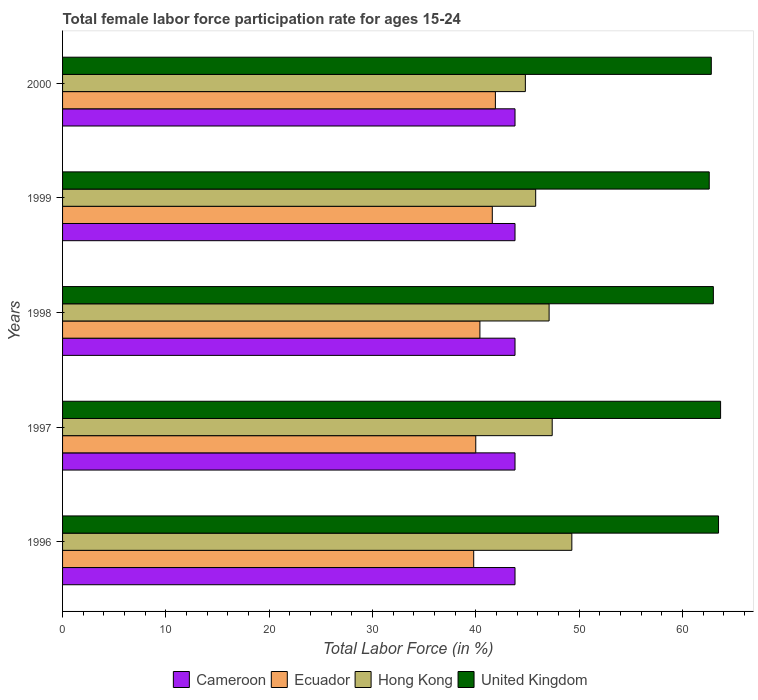How many different coloured bars are there?
Keep it short and to the point. 4. Are the number of bars per tick equal to the number of legend labels?
Your answer should be very brief. Yes. How many bars are there on the 1st tick from the bottom?
Your answer should be compact. 4. What is the label of the 5th group of bars from the top?
Provide a short and direct response. 1996. In how many cases, is the number of bars for a given year not equal to the number of legend labels?
Ensure brevity in your answer.  0. What is the female labor force participation rate in United Kingdom in 1999?
Give a very brief answer. 62.6. Across all years, what is the maximum female labor force participation rate in United Kingdom?
Keep it short and to the point. 63.7. Across all years, what is the minimum female labor force participation rate in United Kingdom?
Ensure brevity in your answer.  62.6. In which year was the female labor force participation rate in Ecuador maximum?
Give a very brief answer. 2000. In which year was the female labor force participation rate in Cameroon minimum?
Your answer should be compact. 1996. What is the total female labor force participation rate in Hong Kong in the graph?
Provide a succinct answer. 234.4. What is the difference between the female labor force participation rate in Cameroon in 1997 and that in 1999?
Your response must be concise. 0. What is the average female labor force participation rate in Cameroon per year?
Offer a terse response. 43.8. In the year 1997, what is the difference between the female labor force participation rate in Cameroon and female labor force participation rate in Ecuador?
Your response must be concise. 3.8. What is the ratio of the female labor force participation rate in Ecuador in 1996 to that in 1998?
Offer a very short reply. 0.99. Is the female labor force participation rate in Hong Kong in 1998 less than that in 1999?
Offer a terse response. No. What is the difference between the highest and the second highest female labor force participation rate in Ecuador?
Ensure brevity in your answer.  0.3. What is the difference between the highest and the lowest female labor force participation rate in United Kingdom?
Offer a terse response. 1.1. In how many years, is the female labor force participation rate in Hong Kong greater than the average female labor force participation rate in Hong Kong taken over all years?
Make the answer very short. 3. What does the 1st bar from the top in 1998 represents?
Ensure brevity in your answer.  United Kingdom. Are all the bars in the graph horizontal?
Offer a terse response. Yes. How many years are there in the graph?
Keep it short and to the point. 5. Does the graph contain grids?
Offer a terse response. No. What is the title of the graph?
Make the answer very short. Total female labor force participation rate for ages 15-24. Does "Mauritius" appear as one of the legend labels in the graph?
Your answer should be compact. No. What is the label or title of the X-axis?
Keep it short and to the point. Total Labor Force (in %). What is the label or title of the Y-axis?
Provide a short and direct response. Years. What is the Total Labor Force (in %) of Cameroon in 1996?
Your answer should be very brief. 43.8. What is the Total Labor Force (in %) in Ecuador in 1996?
Your answer should be very brief. 39.8. What is the Total Labor Force (in %) of Hong Kong in 1996?
Make the answer very short. 49.3. What is the Total Labor Force (in %) in United Kingdom in 1996?
Give a very brief answer. 63.5. What is the Total Labor Force (in %) in Cameroon in 1997?
Give a very brief answer. 43.8. What is the Total Labor Force (in %) in Ecuador in 1997?
Offer a very short reply. 40. What is the Total Labor Force (in %) of Hong Kong in 1997?
Offer a terse response. 47.4. What is the Total Labor Force (in %) in United Kingdom in 1997?
Give a very brief answer. 63.7. What is the Total Labor Force (in %) in Cameroon in 1998?
Offer a very short reply. 43.8. What is the Total Labor Force (in %) in Ecuador in 1998?
Make the answer very short. 40.4. What is the Total Labor Force (in %) in Hong Kong in 1998?
Your answer should be compact. 47.1. What is the Total Labor Force (in %) of United Kingdom in 1998?
Your answer should be compact. 63. What is the Total Labor Force (in %) in Cameroon in 1999?
Provide a short and direct response. 43.8. What is the Total Labor Force (in %) in Ecuador in 1999?
Your answer should be very brief. 41.6. What is the Total Labor Force (in %) of Hong Kong in 1999?
Your answer should be very brief. 45.8. What is the Total Labor Force (in %) in United Kingdom in 1999?
Make the answer very short. 62.6. What is the Total Labor Force (in %) of Cameroon in 2000?
Offer a very short reply. 43.8. What is the Total Labor Force (in %) in Ecuador in 2000?
Offer a very short reply. 41.9. What is the Total Labor Force (in %) of Hong Kong in 2000?
Your answer should be compact. 44.8. What is the Total Labor Force (in %) in United Kingdom in 2000?
Keep it short and to the point. 62.8. Across all years, what is the maximum Total Labor Force (in %) of Cameroon?
Make the answer very short. 43.8. Across all years, what is the maximum Total Labor Force (in %) of Ecuador?
Keep it short and to the point. 41.9. Across all years, what is the maximum Total Labor Force (in %) of Hong Kong?
Your response must be concise. 49.3. Across all years, what is the maximum Total Labor Force (in %) of United Kingdom?
Offer a very short reply. 63.7. Across all years, what is the minimum Total Labor Force (in %) in Cameroon?
Offer a terse response. 43.8. Across all years, what is the minimum Total Labor Force (in %) in Ecuador?
Give a very brief answer. 39.8. Across all years, what is the minimum Total Labor Force (in %) of Hong Kong?
Offer a very short reply. 44.8. Across all years, what is the minimum Total Labor Force (in %) in United Kingdom?
Give a very brief answer. 62.6. What is the total Total Labor Force (in %) in Cameroon in the graph?
Make the answer very short. 219. What is the total Total Labor Force (in %) in Ecuador in the graph?
Give a very brief answer. 203.7. What is the total Total Labor Force (in %) in Hong Kong in the graph?
Keep it short and to the point. 234.4. What is the total Total Labor Force (in %) in United Kingdom in the graph?
Provide a short and direct response. 315.6. What is the difference between the Total Labor Force (in %) of Cameroon in 1996 and that in 1997?
Your response must be concise. 0. What is the difference between the Total Labor Force (in %) in Ecuador in 1996 and that in 1997?
Ensure brevity in your answer.  -0.2. What is the difference between the Total Labor Force (in %) in United Kingdom in 1996 and that in 1997?
Offer a terse response. -0.2. What is the difference between the Total Labor Force (in %) in Cameroon in 1996 and that in 1998?
Offer a terse response. 0. What is the difference between the Total Labor Force (in %) of Ecuador in 1996 and that in 1998?
Provide a succinct answer. -0.6. What is the difference between the Total Labor Force (in %) in Hong Kong in 1996 and that in 1998?
Provide a succinct answer. 2.2. What is the difference between the Total Labor Force (in %) of Ecuador in 1996 and that in 1999?
Your answer should be very brief. -1.8. What is the difference between the Total Labor Force (in %) in Hong Kong in 1996 and that in 1999?
Provide a short and direct response. 3.5. What is the difference between the Total Labor Force (in %) in Ecuador in 1996 and that in 2000?
Keep it short and to the point. -2.1. What is the difference between the Total Labor Force (in %) in Hong Kong in 1996 and that in 2000?
Provide a succinct answer. 4.5. What is the difference between the Total Labor Force (in %) of United Kingdom in 1996 and that in 2000?
Offer a very short reply. 0.7. What is the difference between the Total Labor Force (in %) of United Kingdom in 1997 and that in 1998?
Offer a very short reply. 0.7. What is the difference between the Total Labor Force (in %) in Cameroon in 1997 and that in 1999?
Make the answer very short. 0. What is the difference between the Total Labor Force (in %) of United Kingdom in 1997 and that in 1999?
Make the answer very short. 1.1. What is the difference between the Total Labor Force (in %) in Ecuador in 1997 and that in 2000?
Provide a succinct answer. -1.9. What is the difference between the Total Labor Force (in %) of Hong Kong in 1997 and that in 2000?
Your response must be concise. 2.6. What is the difference between the Total Labor Force (in %) in Ecuador in 1998 and that in 2000?
Keep it short and to the point. -1.5. What is the difference between the Total Labor Force (in %) in Hong Kong in 1998 and that in 2000?
Offer a terse response. 2.3. What is the difference between the Total Labor Force (in %) in United Kingdom in 1998 and that in 2000?
Make the answer very short. 0.2. What is the difference between the Total Labor Force (in %) of Ecuador in 1999 and that in 2000?
Your answer should be very brief. -0.3. What is the difference between the Total Labor Force (in %) of United Kingdom in 1999 and that in 2000?
Offer a very short reply. -0.2. What is the difference between the Total Labor Force (in %) in Cameroon in 1996 and the Total Labor Force (in %) in Ecuador in 1997?
Keep it short and to the point. 3.8. What is the difference between the Total Labor Force (in %) in Cameroon in 1996 and the Total Labor Force (in %) in United Kingdom in 1997?
Offer a terse response. -19.9. What is the difference between the Total Labor Force (in %) in Ecuador in 1996 and the Total Labor Force (in %) in United Kingdom in 1997?
Your response must be concise. -23.9. What is the difference between the Total Labor Force (in %) in Hong Kong in 1996 and the Total Labor Force (in %) in United Kingdom in 1997?
Give a very brief answer. -14.4. What is the difference between the Total Labor Force (in %) of Cameroon in 1996 and the Total Labor Force (in %) of United Kingdom in 1998?
Make the answer very short. -19.2. What is the difference between the Total Labor Force (in %) of Ecuador in 1996 and the Total Labor Force (in %) of United Kingdom in 1998?
Your answer should be very brief. -23.2. What is the difference between the Total Labor Force (in %) in Hong Kong in 1996 and the Total Labor Force (in %) in United Kingdom in 1998?
Keep it short and to the point. -13.7. What is the difference between the Total Labor Force (in %) in Cameroon in 1996 and the Total Labor Force (in %) in Ecuador in 1999?
Offer a terse response. 2.2. What is the difference between the Total Labor Force (in %) in Cameroon in 1996 and the Total Labor Force (in %) in Hong Kong in 1999?
Your response must be concise. -2. What is the difference between the Total Labor Force (in %) of Cameroon in 1996 and the Total Labor Force (in %) of United Kingdom in 1999?
Ensure brevity in your answer.  -18.8. What is the difference between the Total Labor Force (in %) of Ecuador in 1996 and the Total Labor Force (in %) of Hong Kong in 1999?
Your answer should be compact. -6. What is the difference between the Total Labor Force (in %) of Ecuador in 1996 and the Total Labor Force (in %) of United Kingdom in 1999?
Keep it short and to the point. -22.8. What is the difference between the Total Labor Force (in %) of Cameroon in 1996 and the Total Labor Force (in %) of Hong Kong in 2000?
Your answer should be very brief. -1. What is the difference between the Total Labor Force (in %) of Ecuador in 1996 and the Total Labor Force (in %) of Hong Kong in 2000?
Provide a short and direct response. -5. What is the difference between the Total Labor Force (in %) in Cameroon in 1997 and the Total Labor Force (in %) in Ecuador in 1998?
Your response must be concise. 3.4. What is the difference between the Total Labor Force (in %) of Cameroon in 1997 and the Total Labor Force (in %) of United Kingdom in 1998?
Your answer should be very brief. -19.2. What is the difference between the Total Labor Force (in %) of Ecuador in 1997 and the Total Labor Force (in %) of Hong Kong in 1998?
Provide a succinct answer. -7.1. What is the difference between the Total Labor Force (in %) in Ecuador in 1997 and the Total Labor Force (in %) in United Kingdom in 1998?
Ensure brevity in your answer.  -23. What is the difference between the Total Labor Force (in %) of Hong Kong in 1997 and the Total Labor Force (in %) of United Kingdom in 1998?
Your answer should be compact. -15.6. What is the difference between the Total Labor Force (in %) in Cameroon in 1997 and the Total Labor Force (in %) in Hong Kong in 1999?
Your response must be concise. -2. What is the difference between the Total Labor Force (in %) of Cameroon in 1997 and the Total Labor Force (in %) of United Kingdom in 1999?
Your answer should be compact. -18.8. What is the difference between the Total Labor Force (in %) in Ecuador in 1997 and the Total Labor Force (in %) in Hong Kong in 1999?
Ensure brevity in your answer.  -5.8. What is the difference between the Total Labor Force (in %) in Ecuador in 1997 and the Total Labor Force (in %) in United Kingdom in 1999?
Offer a terse response. -22.6. What is the difference between the Total Labor Force (in %) in Hong Kong in 1997 and the Total Labor Force (in %) in United Kingdom in 1999?
Give a very brief answer. -15.2. What is the difference between the Total Labor Force (in %) of Cameroon in 1997 and the Total Labor Force (in %) of Ecuador in 2000?
Provide a succinct answer. 1.9. What is the difference between the Total Labor Force (in %) of Cameroon in 1997 and the Total Labor Force (in %) of United Kingdom in 2000?
Offer a very short reply. -19. What is the difference between the Total Labor Force (in %) in Ecuador in 1997 and the Total Labor Force (in %) in United Kingdom in 2000?
Your answer should be compact. -22.8. What is the difference between the Total Labor Force (in %) in Hong Kong in 1997 and the Total Labor Force (in %) in United Kingdom in 2000?
Ensure brevity in your answer.  -15.4. What is the difference between the Total Labor Force (in %) of Cameroon in 1998 and the Total Labor Force (in %) of Ecuador in 1999?
Ensure brevity in your answer.  2.2. What is the difference between the Total Labor Force (in %) in Cameroon in 1998 and the Total Labor Force (in %) in Hong Kong in 1999?
Ensure brevity in your answer.  -2. What is the difference between the Total Labor Force (in %) of Cameroon in 1998 and the Total Labor Force (in %) of United Kingdom in 1999?
Keep it short and to the point. -18.8. What is the difference between the Total Labor Force (in %) in Ecuador in 1998 and the Total Labor Force (in %) in United Kingdom in 1999?
Make the answer very short. -22.2. What is the difference between the Total Labor Force (in %) in Hong Kong in 1998 and the Total Labor Force (in %) in United Kingdom in 1999?
Keep it short and to the point. -15.5. What is the difference between the Total Labor Force (in %) in Cameroon in 1998 and the Total Labor Force (in %) in Ecuador in 2000?
Your answer should be very brief. 1.9. What is the difference between the Total Labor Force (in %) of Cameroon in 1998 and the Total Labor Force (in %) of United Kingdom in 2000?
Offer a terse response. -19. What is the difference between the Total Labor Force (in %) of Ecuador in 1998 and the Total Labor Force (in %) of United Kingdom in 2000?
Offer a very short reply. -22.4. What is the difference between the Total Labor Force (in %) of Hong Kong in 1998 and the Total Labor Force (in %) of United Kingdom in 2000?
Your response must be concise. -15.7. What is the difference between the Total Labor Force (in %) of Cameroon in 1999 and the Total Labor Force (in %) of Ecuador in 2000?
Your answer should be very brief. 1.9. What is the difference between the Total Labor Force (in %) in Ecuador in 1999 and the Total Labor Force (in %) in Hong Kong in 2000?
Keep it short and to the point. -3.2. What is the difference between the Total Labor Force (in %) in Ecuador in 1999 and the Total Labor Force (in %) in United Kingdom in 2000?
Offer a terse response. -21.2. What is the difference between the Total Labor Force (in %) of Hong Kong in 1999 and the Total Labor Force (in %) of United Kingdom in 2000?
Your response must be concise. -17. What is the average Total Labor Force (in %) of Cameroon per year?
Your response must be concise. 43.8. What is the average Total Labor Force (in %) of Ecuador per year?
Your answer should be very brief. 40.74. What is the average Total Labor Force (in %) in Hong Kong per year?
Your answer should be compact. 46.88. What is the average Total Labor Force (in %) of United Kingdom per year?
Offer a terse response. 63.12. In the year 1996, what is the difference between the Total Labor Force (in %) of Cameroon and Total Labor Force (in %) of Hong Kong?
Your answer should be very brief. -5.5. In the year 1996, what is the difference between the Total Labor Force (in %) in Cameroon and Total Labor Force (in %) in United Kingdom?
Offer a terse response. -19.7. In the year 1996, what is the difference between the Total Labor Force (in %) in Ecuador and Total Labor Force (in %) in United Kingdom?
Make the answer very short. -23.7. In the year 1997, what is the difference between the Total Labor Force (in %) of Cameroon and Total Labor Force (in %) of Ecuador?
Provide a succinct answer. 3.8. In the year 1997, what is the difference between the Total Labor Force (in %) in Cameroon and Total Labor Force (in %) in United Kingdom?
Provide a succinct answer. -19.9. In the year 1997, what is the difference between the Total Labor Force (in %) in Ecuador and Total Labor Force (in %) in United Kingdom?
Provide a short and direct response. -23.7. In the year 1997, what is the difference between the Total Labor Force (in %) of Hong Kong and Total Labor Force (in %) of United Kingdom?
Provide a succinct answer. -16.3. In the year 1998, what is the difference between the Total Labor Force (in %) of Cameroon and Total Labor Force (in %) of United Kingdom?
Give a very brief answer. -19.2. In the year 1998, what is the difference between the Total Labor Force (in %) in Ecuador and Total Labor Force (in %) in Hong Kong?
Provide a succinct answer. -6.7. In the year 1998, what is the difference between the Total Labor Force (in %) in Ecuador and Total Labor Force (in %) in United Kingdom?
Provide a succinct answer. -22.6. In the year 1998, what is the difference between the Total Labor Force (in %) in Hong Kong and Total Labor Force (in %) in United Kingdom?
Your answer should be very brief. -15.9. In the year 1999, what is the difference between the Total Labor Force (in %) of Cameroon and Total Labor Force (in %) of Ecuador?
Your answer should be very brief. 2.2. In the year 1999, what is the difference between the Total Labor Force (in %) of Cameroon and Total Labor Force (in %) of Hong Kong?
Make the answer very short. -2. In the year 1999, what is the difference between the Total Labor Force (in %) of Cameroon and Total Labor Force (in %) of United Kingdom?
Give a very brief answer. -18.8. In the year 1999, what is the difference between the Total Labor Force (in %) in Ecuador and Total Labor Force (in %) in United Kingdom?
Give a very brief answer. -21. In the year 1999, what is the difference between the Total Labor Force (in %) of Hong Kong and Total Labor Force (in %) of United Kingdom?
Provide a short and direct response. -16.8. In the year 2000, what is the difference between the Total Labor Force (in %) of Cameroon and Total Labor Force (in %) of Ecuador?
Offer a very short reply. 1.9. In the year 2000, what is the difference between the Total Labor Force (in %) of Cameroon and Total Labor Force (in %) of United Kingdom?
Give a very brief answer. -19. In the year 2000, what is the difference between the Total Labor Force (in %) of Ecuador and Total Labor Force (in %) of Hong Kong?
Make the answer very short. -2.9. In the year 2000, what is the difference between the Total Labor Force (in %) of Ecuador and Total Labor Force (in %) of United Kingdom?
Your answer should be compact. -20.9. What is the ratio of the Total Labor Force (in %) of Cameroon in 1996 to that in 1997?
Provide a short and direct response. 1. What is the ratio of the Total Labor Force (in %) in Ecuador in 1996 to that in 1997?
Your answer should be very brief. 0.99. What is the ratio of the Total Labor Force (in %) in Hong Kong in 1996 to that in 1997?
Provide a short and direct response. 1.04. What is the ratio of the Total Labor Force (in %) in Cameroon in 1996 to that in 1998?
Make the answer very short. 1. What is the ratio of the Total Labor Force (in %) of Ecuador in 1996 to that in 1998?
Offer a terse response. 0.99. What is the ratio of the Total Labor Force (in %) in Hong Kong in 1996 to that in 1998?
Provide a short and direct response. 1.05. What is the ratio of the Total Labor Force (in %) in United Kingdom in 1996 to that in 1998?
Your response must be concise. 1.01. What is the ratio of the Total Labor Force (in %) in Ecuador in 1996 to that in 1999?
Keep it short and to the point. 0.96. What is the ratio of the Total Labor Force (in %) of Hong Kong in 1996 to that in 1999?
Keep it short and to the point. 1.08. What is the ratio of the Total Labor Force (in %) in United Kingdom in 1996 to that in 1999?
Give a very brief answer. 1.01. What is the ratio of the Total Labor Force (in %) in Ecuador in 1996 to that in 2000?
Offer a very short reply. 0.95. What is the ratio of the Total Labor Force (in %) in Hong Kong in 1996 to that in 2000?
Keep it short and to the point. 1.1. What is the ratio of the Total Labor Force (in %) of United Kingdom in 1996 to that in 2000?
Ensure brevity in your answer.  1.01. What is the ratio of the Total Labor Force (in %) in Cameroon in 1997 to that in 1998?
Your answer should be very brief. 1. What is the ratio of the Total Labor Force (in %) in Hong Kong in 1997 to that in 1998?
Keep it short and to the point. 1.01. What is the ratio of the Total Labor Force (in %) in United Kingdom in 1997 to that in 1998?
Offer a very short reply. 1.01. What is the ratio of the Total Labor Force (in %) in Ecuador in 1997 to that in 1999?
Keep it short and to the point. 0.96. What is the ratio of the Total Labor Force (in %) of Hong Kong in 1997 to that in 1999?
Give a very brief answer. 1.03. What is the ratio of the Total Labor Force (in %) of United Kingdom in 1997 to that in 1999?
Offer a very short reply. 1.02. What is the ratio of the Total Labor Force (in %) in Cameroon in 1997 to that in 2000?
Your answer should be compact. 1. What is the ratio of the Total Labor Force (in %) in Ecuador in 1997 to that in 2000?
Offer a terse response. 0.95. What is the ratio of the Total Labor Force (in %) of Hong Kong in 1997 to that in 2000?
Give a very brief answer. 1.06. What is the ratio of the Total Labor Force (in %) in United Kingdom in 1997 to that in 2000?
Offer a terse response. 1.01. What is the ratio of the Total Labor Force (in %) in Ecuador in 1998 to that in 1999?
Provide a short and direct response. 0.97. What is the ratio of the Total Labor Force (in %) of Hong Kong in 1998 to that in 1999?
Your answer should be very brief. 1.03. What is the ratio of the Total Labor Force (in %) of United Kingdom in 1998 to that in 1999?
Make the answer very short. 1.01. What is the ratio of the Total Labor Force (in %) in Cameroon in 1998 to that in 2000?
Provide a short and direct response. 1. What is the ratio of the Total Labor Force (in %) in Ecuador in 1998 to that in 2000?
Give a very brief answer. 0.96. What is the ratio of the Total Labor Force (in %) of Hong Kong in 1998 to that in 2000?
Provide a short and direct response. 1.05. What is the ratio of the Total Labor Force (in %) of Cameroon in 1999 to that in 2000?
Your response must be concise. 1. What is the ratio of the Total Labor Force (in %) in Ecuador in 1999 to that in 2000?
Provide a succinct answer. 0.99. What is the ratio of the Total Labor Force (in %) in Hong Kong in 1999 to that in 2000?
Give a very brief answer. 1.02. What is the ratio of the Total Labor Force (in %) in United Kingdom in 1999 to that in 2000?
Keep it short and to the point. 1. What is the difference between the highest and the second highest Total Labor Force (in %) of Cameroon?
Ensure brevity in your answer.  0. What is the difference between the highest and the second highest Total Labor Force (in %) in United Kingdom?
Your answer should be compact. 0.2. What is the difference between the highest and the lowest Total Labor Force (in %) in Cameroon?
Your answer should be compact. 0. What is the difference between the highest and the lowest Total Labor Force (in %) in Ecuador?
Keep it short and to the point. 2.1. What is the difference between the highest and the lowest Total Labor Force (in %) in Hong Kong?
Give a very brief answer. 4.5. 